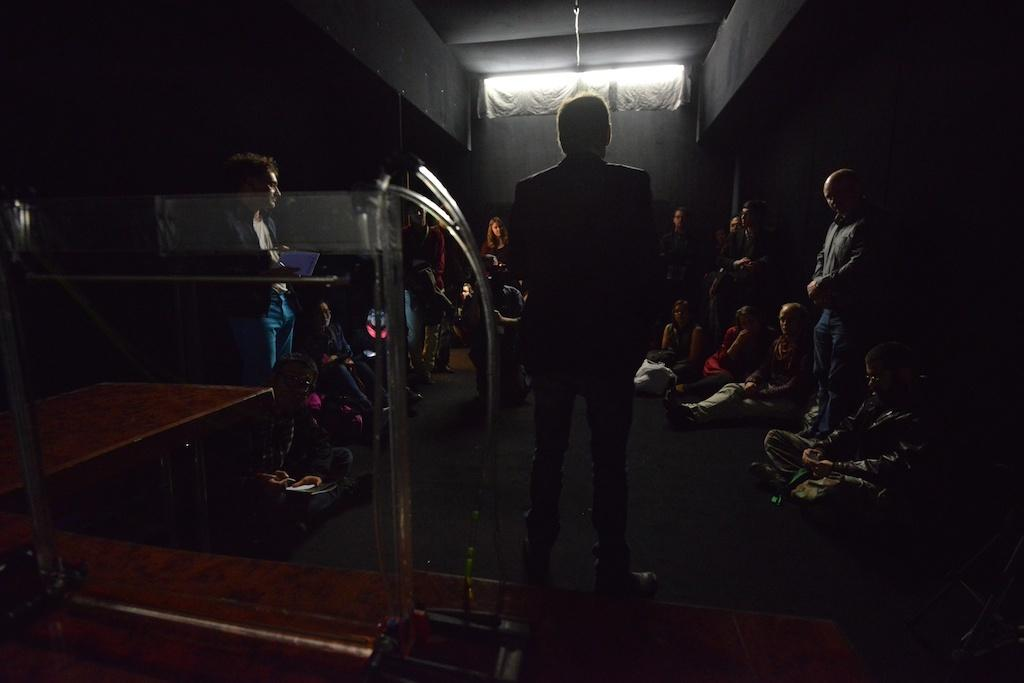What type of location is depicted in the image? The image is an inside view of a building. What are the people in the image doing? Some people are standing, while others are sitting in the image. Can you describe any objects or structures in the image? There is a stand visible in the image. What shape is the bean that is being selected by the people in the image? There is no bean present in the image, and therefore no shape or selection can be observed. 